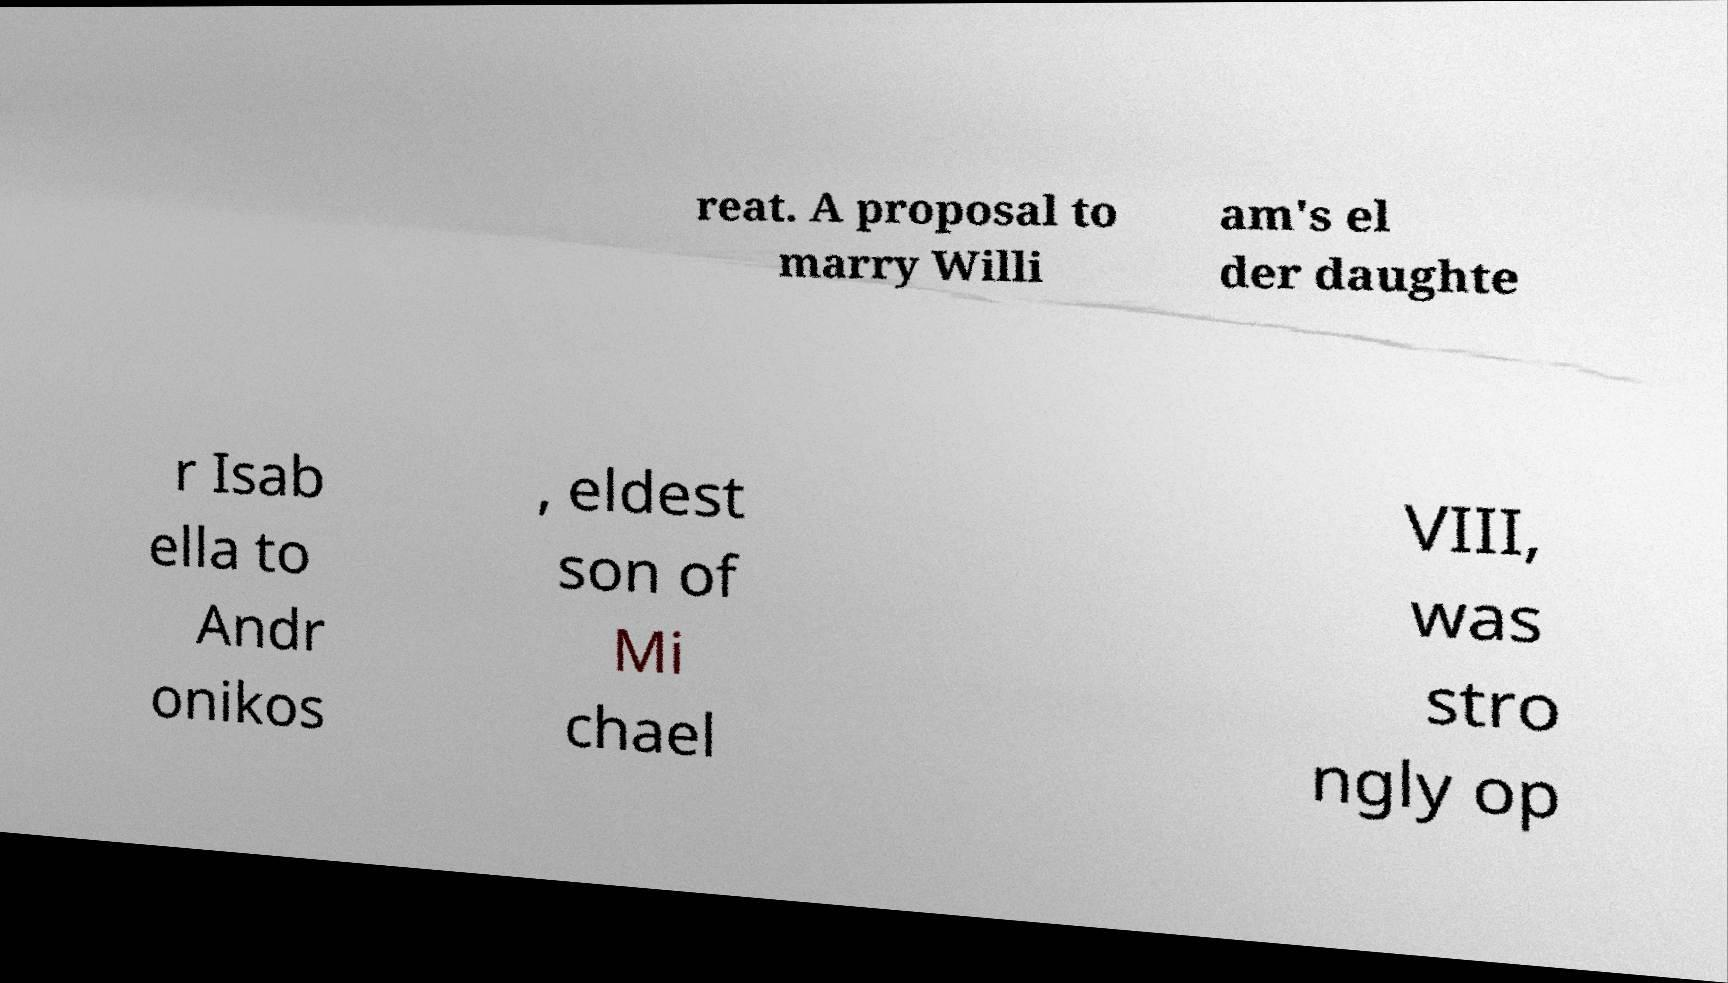Please read and relay the text visible in this image. What does it say? reat. A proposal to marry Willi am's el der daughte r Isab ella to Andr onikos , eldest son of Mi chael VIII, was stro ngly op 